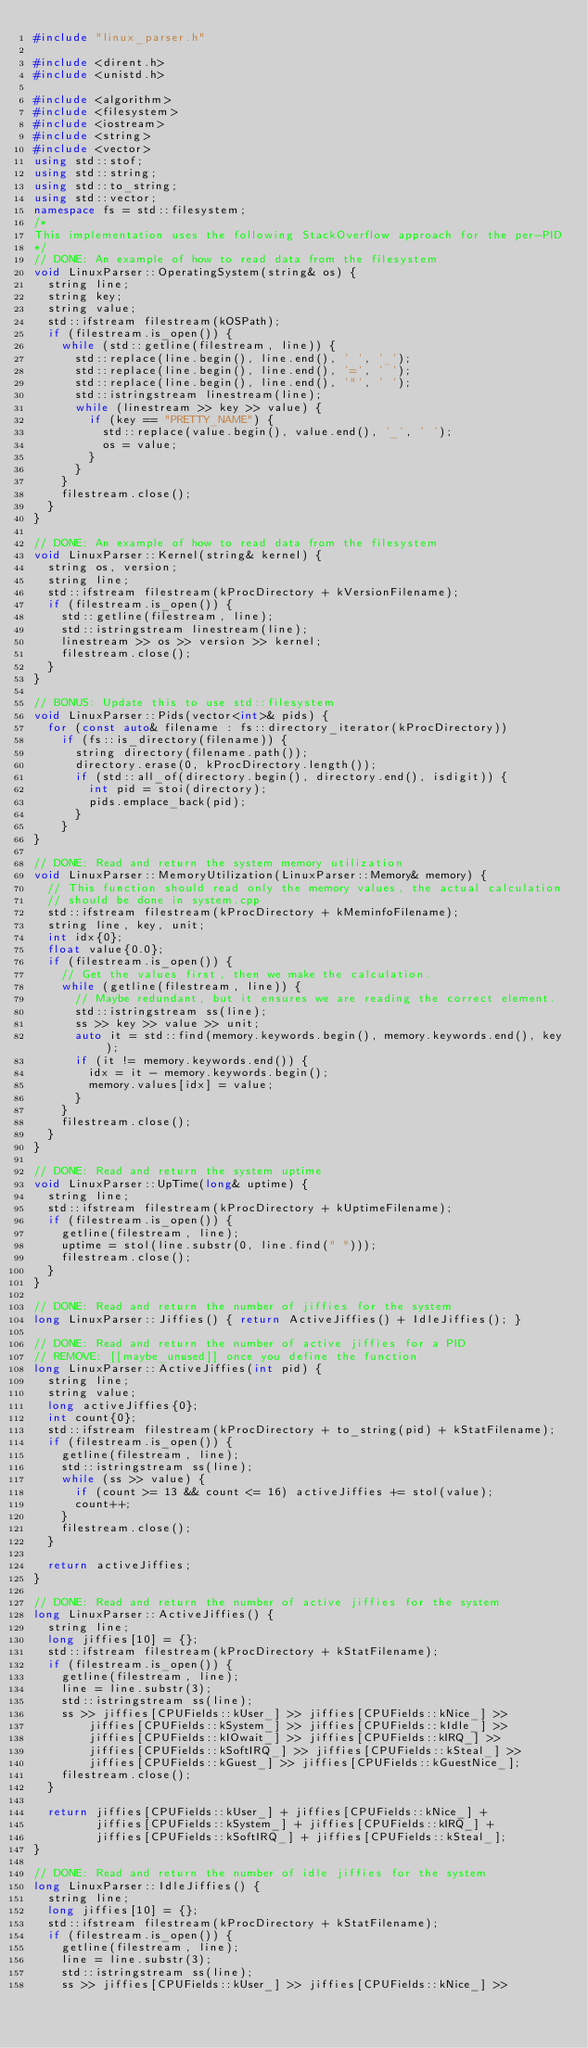<code> <loc_0><loc_0><loc_500><loc_500><_C++_>#include "linux_parser.h"

#include <dirent.h>
#include <unistd.h>

#include <algorithm>
#include <filesystem>
#include <iostream>
#include <string>
#include <vector>
using std::stof;
using std::string;
using std::to_string;
using std::vector;
namespace fs = std::filesystem;
/*
This implementation uses the following StackOverflow approach for the per-PID
*/
// DONE: An example of how to read data from the filesystem
void LinuxParser::OperatingSystem(string& os) {
  string line;
  string key;
  string value;
  std::ifstream filestream(kOSPath);
  if (filestream.is_open()) {
    while (std::getline(filestream, line)) {
      std::replace(line.begin(), line.end(), ' ', '_');
      std::replace(line.begin(), line.end(), '=', ' ');
      std::replace(line.begin(), line.end(), '"', ' ');
      std::istringstream linestream(line);
      while (linestream >> key >> value) {
        if (key == "PRETTY_NAME") {
          std::replace(value.begin(), value.end(), '_', ' ');
          os = value;
        }
      }
    }
    filestream.close();
  }
}

// DONE: An example of how to read data from the filesystem
void LinuxParser::Kernel(string& kernel) {
  string os, version;
  string line;
  std::ifstream filestream(kProcDirectory + kVersionFilename);
  if (filestream.is_open()) {
    std::getline(filestream, line);
    std::istringstream linestream(line);
    linestream >> os >> version >> kernel;
    filestream.close();
  }
}

// BONUS: Update this to use std::filesystem
void LinuxParser::Pids(vector<int>& pids) {
  for (const auto& filename : fs::directory_iterator(kProcDirectory))
    if (fs::is_directory(filename)) {
      string directory(filename.path());
      directory.erase(0, kProcDirectory.length());
      if (std::all_of(directory.begin(), directory.end(), isdigit)) {
        int pid = stoi(directory);
        pids.emplace_back(pid);
      }
    }
}

// DONE: Read and return the system memory utilization
void LinuxParser::MemoryUtilization(LinuxParser::Memory& memory) {
  // This function should read only the memory values, the actual calculation
  // should be done in system.cpp
  std::ifstream filestream(kProcDirectory + kMeminfoFilename);
  string line, key, unit;
  int idx{0};
  float value{0.0};
  if (filestream.is_open()) {
    // Get the values first, then we make the calculation.
    while (getline(filestream, line)) {
      // Maybe redundant, but it ensures we are reading the correct element.
      std::istringstream ss(line);
      ss >> key >> value >> unit;
      auto it = std::find(memory.keywords.begin(), memory.keywords.end(), key);
      if (it != memory.keywords.end()) {
        idx = it - memory.keywords.begin();
        memory.values[idx] = value;
      }
    }
    filestream.close();
  }
}

// DONE: Read and return the system uptime
void LinuxParser::UpTime(long& uptime) {
  string line;
  std::ifstream filestream(kProcDirectory + kUptimeFilename);
  if (filestream.is_open()) {
    getline(filestream, line);
    uptime = stol(line.substr(0, line.find(" ")));
    filestream.close();
  }
}

// DONE: Read and return the number of jiffies for the system
long LinuxParser::Jiffies() { return ActiveJiffies() + IdleJiffies(); }

// DONE: Read and return the number of active jiffies for a PID
// REMOVE: [[maybe_unused]] once you define the function
long LinuxParser::ActiveJiffies(int pid) {
  string line;
  string value;
  long activeJiffies{0};
  int count{0};
  std::ifstream filestream(kProcDirectory + to_string(pid) + kStatFilename);
  if (filestream.is_open()) {
    getline(filestream, line);
    std::istringstream ss(line);
    while (ss >> value) {
      if (count >= 13 && count <= 16) activeJiffies += stol(value);
      count++;
    }
    filestream.close();
  }

  return activeJiffies;
}

// DONE: Read and return the number of active jiffies for the system
long LinuxParser::ActiveJiffies() {
  string line;
  long jiffies[10] = {};
  std::ifstream filestream(kProcDirectory + kStatFilename);
  if (filestream.is_open()) {
    getline(filestream, line);
    line = line.substr(3);
    std::istringstream ss(line);
    ss >> jiffies[CPUFields::kUser_] >> jiffies[CPUFields::kNice_] >>
        jiffies[CPUFields::kSystem_] >> jiffies[CPUFields::kIdle_] >>
        jiffies[CPUFields::kIOwait_] >> jiffies[CPUFields::kIRQ_] >>
        jiffies[CPUFields::kSoftIRQ_] >> jiffies[CPUFields::kSteal_] >>
        jiffies[CPUFields::kGuest_] >> jiffies[CPUFields::kGuestNice_];
    filestream.close();
  }

  return jiffies[CPUFields::kUser_] + jiffies[CPUFields::kNice_] +
         jiffies[CPUFields::kSystem_] + jiffies[CPUFields::kIRQ_] +
         jiffies[CPUFields::kSoftIRQ_] + jiffies[CPUFields::kSteal_];
}

// DONE: Read and return the number of idle jiffies for the system
long LinuxParser::IdleJiffies() {
  string line;
  long jiffies[10] = {};
  std::ifstream filestream(kProcDirectory + kStatFilename);
  if (filestream.is_open()) {
    getline(filestream, line);
    line = line.substr(3);
    std::istringstream ss(line);
    ss >> jiffies[CPUFields::kUser_] >> jiffies[CPUFields::kNice_] >></code> 